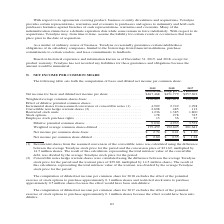According to Teradyne's financial document, How were the Incremental shares from assumed conversion of convertible notes calculated? calculated using the difference between the average Teradyne stock price for the period and the conversion price of $31.62, multiplied by 14.5 million shares.. The document states: "he assumed conversion of the convertible notes was calculated using the difference between the average Teradyne stock price for the period and the con..." Also, How were the Convertible note hedge warrant shares calculated? calculated using the difference between the average Teradyne stock price for the period and the warrant price of $39.68, multiplied by 14.5 million shares. The document states: ". (2) Convertible notes hedge warrant shares were calculated using the difference between the average Teradyne stock price for the period and the warr..." Also, In which years was the net income pre common share calculated? The document contains multiple relevant values: 2019, 2018, 2017. From the document: "2019 2018 2017 2019 2018 2017 2019 2018 2017..." Additionally, In which year were the Employee stock purchase rights the largest? According to the financial document, 2018. The relevant text states: "2019 2018 2017..." Also, can you calculate: What was the change in Net income per common share-diluted in 2019 from 2018? Based on the calculation: 2.60-2.35, the result is 0.25. This is based on the information: "Net income per common share-diluted . $ 2.60 $ 2.35 $ 1.28 Net income per common share-diluted . $ 2.60 $ 2.35 $ 1.28..." The key data points involved are: 2.35, 2.60. Also, can you calculate: What was the percentage change in Net income per common share-diluted in 2019 from 2018? To answer this question, I need to perform calculations using the financial data. The calculation is: (2.60-2.35)/2.35, which equals 10.64 (percentage). This is based on the information: "Net income per common share-diluted . $ 2.60 $ 2.35 $ 1.28 Net income per common share-diluted . $ 2.60 $ 2.35 $ 1.28..." The key data points involved are: 2.35, 2.60. 